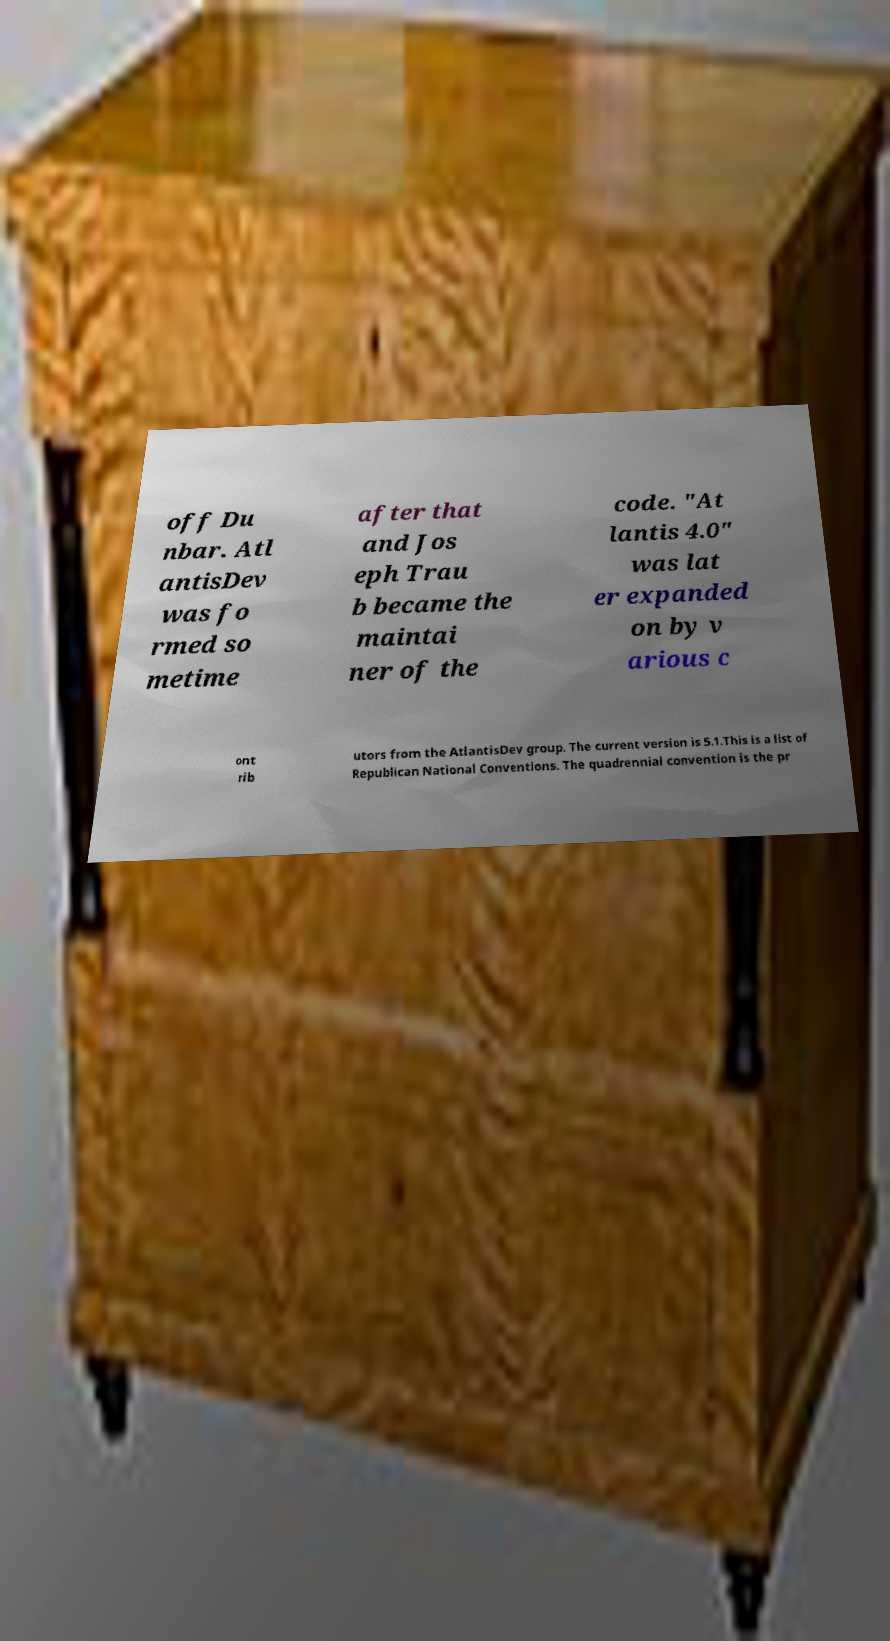Could you assist in decoding the text presented in this image and type it out clearly? off Du nbar. Atl antisDev was fo rmed so metime after that and Jos eph Trau b became the maintai ner of the code. "At lantis 4.0" was lat er expanded on by v arious c ont rib utors from the AtlantisDev group. The current version is 5.1.This is a list of Republican National Conventions. The quadrennial convention is the pr 